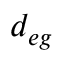Convert formula to latex. <formula><loc_0><loc_0><loc_500><loc_500>d _ { e g }</formula> 